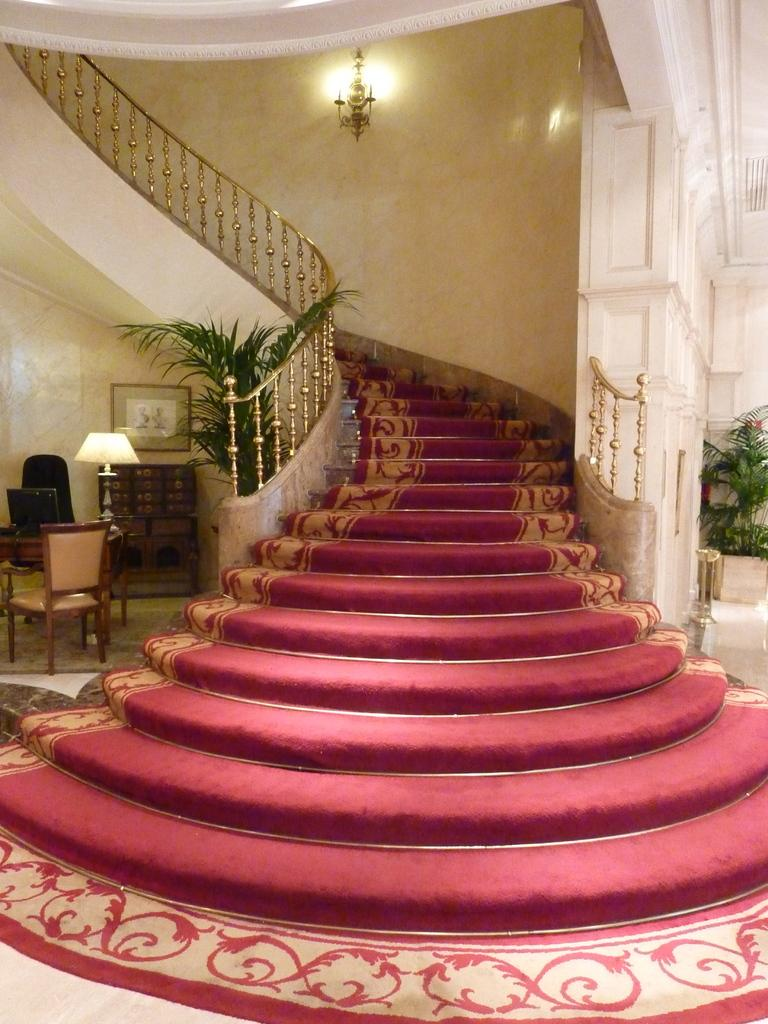What type of flooring is used on the staircase in the image? The staircase in the image has carpet strips. What other objects can be seen in the image besides the staircase? There are plants, a chair, a monitor on a table, a lamp, and a frame in the image. Where is the light source located in the image? There is a light attached to the wall in the image. What type of advertisement can be seen on the coach in the image? There is no coach or advertisement present in the image. 